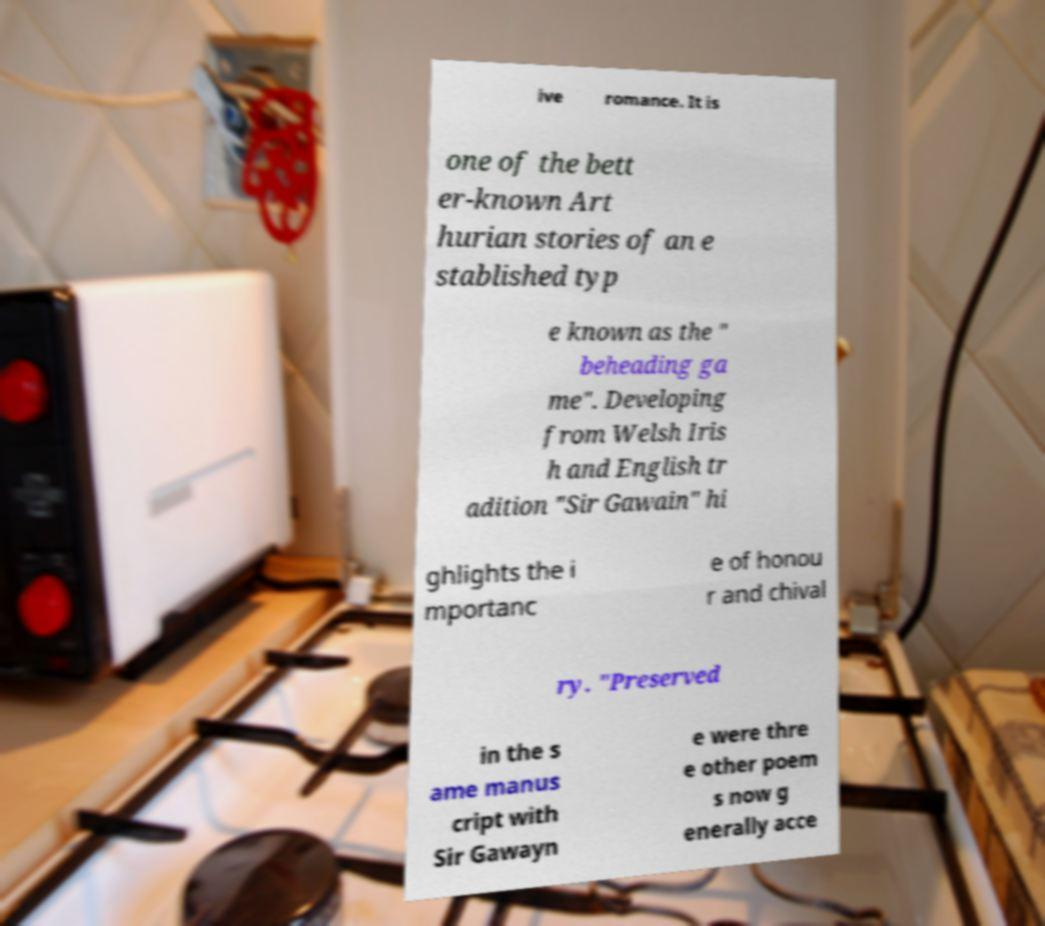Could you extract and type out the text from this image? ive romance. It is one of the bett er-known Art hurian stories of an e stablished typ e known as the " beheading ga me". Developing from Welsh Iris h and English tr adition "Sir Gawain" hi ghlights the i mportanc e of honou r and chival ry. "Preserved in the s ame manus cript with Sir Gawayn e were thre e other poem s now g enerally acce 